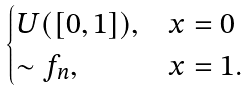<formula> <loc_0><loc_0><loc_500><loc_500>\begin{cases} U ( [ 0 , 1 ] ) , & x = 0 \\ \sim f _ { n } , & x = 1 . \end{cases}</formula> 